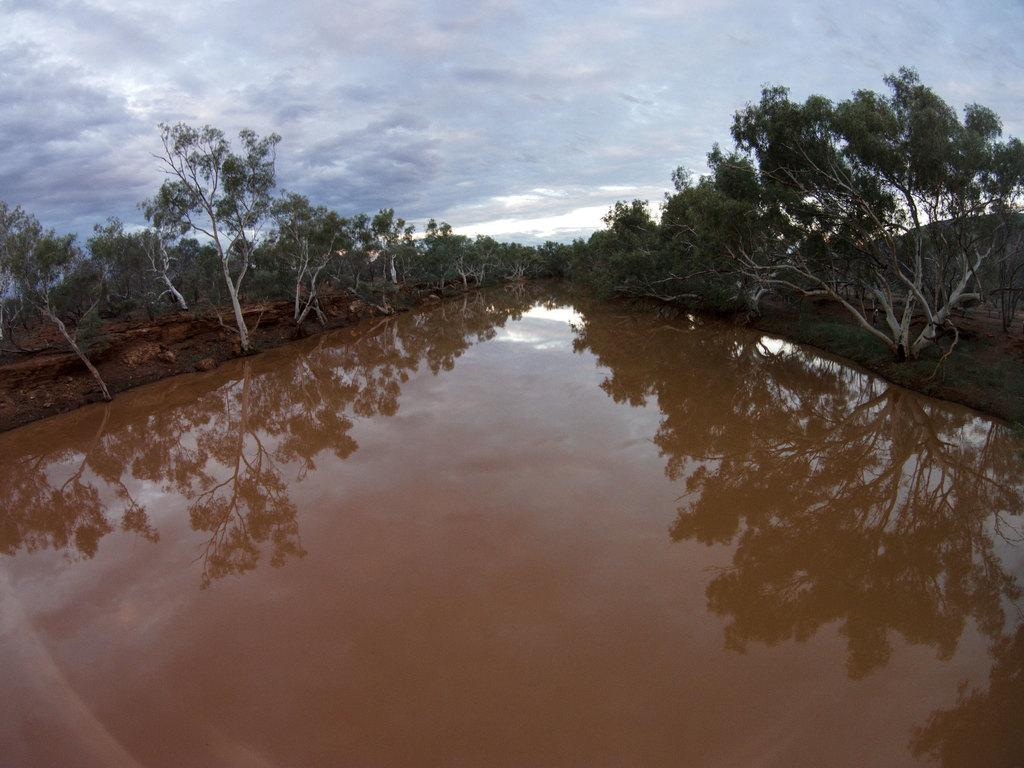What type of water feature is in the image? There is a canal in the image. What can be seen near the canal? Trees are present near the canal. What is visible at the top of the image? The sky is visible at the top of the image. What type of art can be seen on the surface of the water in the image? There is no art visible on the surface of the water in the image; it is a natural scene with a canal, trees, and sky. 